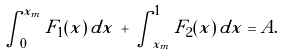Convert formula to latex. <formula><loc_0><loc_0><loc_500><loc_500>\int _ { 0 } ^ { x _ { m } } F _ { 1 } ( x ) \, d x \, + \, \int _ { x _ { m } } ^ { 1 } F _ { 2 } ( x ) \, d x = A .</formula> 